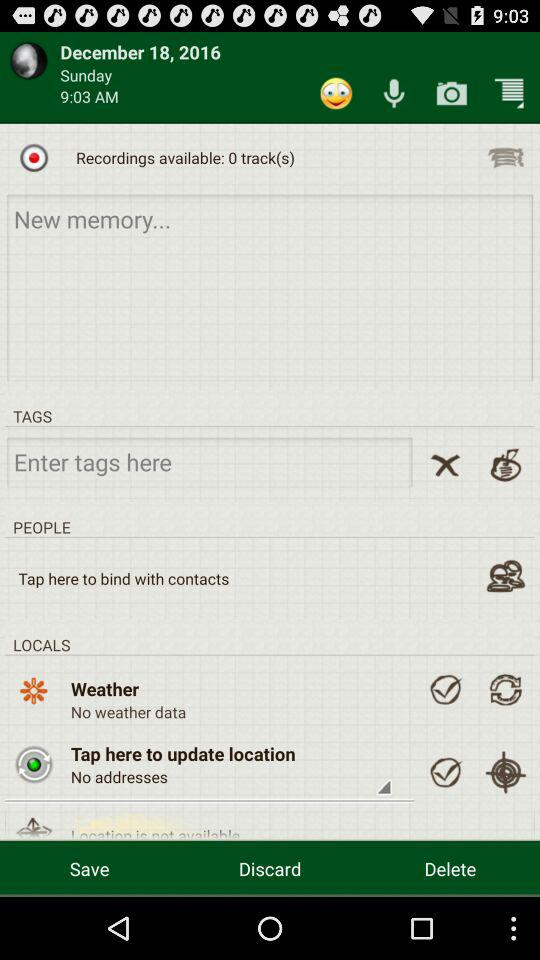What is the time? The time is 9:03 AM. 